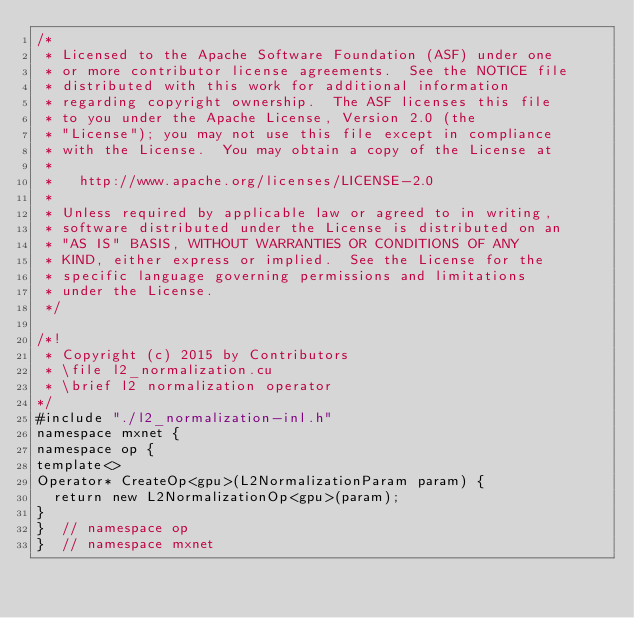<code> <loc_0><loc_0><loc_500><loc_500><_Cuda_>/*
 * Licensed to the Apache Software Foundation (ASF) under one
 * or more contributor license agreements.  See the NOTICE file
 * distributed with this work for additional information
 * regarding copyright ownership.  The ASF licenses this file
 * to you under the Apache License, Version 2.0 (the
 * "License"); you may not use this file except in compliance
 * with the License.  You may obtain a copy of the License at
 *
 *   http://www.apache.org/licenses/LICENSE-2.0
 *
 * Unless required by applicable law or agreed to in writing,
 * software distributed under the License is distributed on an
 * "AS IS" BASIS, WITHOUT WARRANTIES OR CONDITIONS OF ANY
 * KIND, either express or implied.  See the License for the
 * specific language governing permissions and limitations
 * under the License.
 */

/*!
 * Copyright (c) 2015 by Contributors
 * \file l2_normalization.cu
 * \brief l2 normalization operator
*/
#include "./l2_normalization-inl.h"
namespace mxnet {
namespace op {
template<>
Operator* CreateOp<gpu>(L2NormalizationParam param) {
  return new L2NormalizationOp<gpu>(param);
}
}  // namespace op
}  // namespace mxnet
</code> 